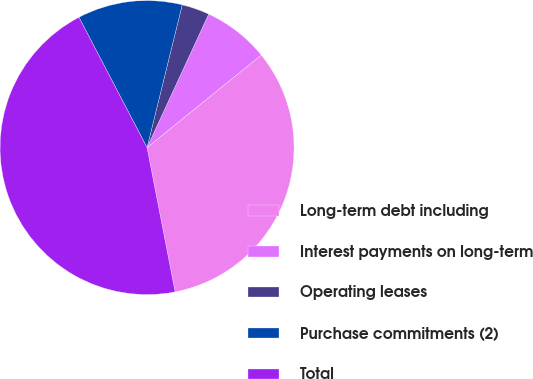Convert chart to OTSL. <chart><loc_0><loc_0><loc_500><loc_500><pie_chart><fcel>Long-term debt including<fcel>Interest payments on long-term<fcel>Operating leases<fcel>Purchase commitments (2)<fcel>Total<nl><fcel>32.77%<fcel>7.28%<fcel>3.04%<fcel>11.51%<fcel>45.39%<nl></chart> 